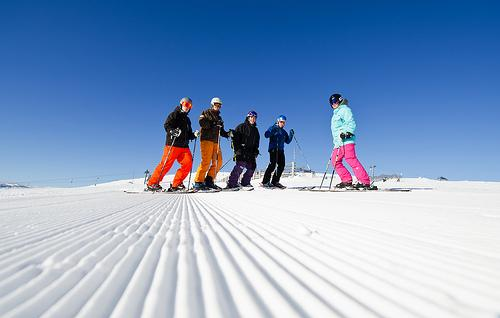Assess the sentiment conveyed by the image, taking into account the atmosphere and human activity. The image evokes a sense of excitement, joy and adventurousness, as people are enjoying skiing outdoors on a beautiful day with clear blue skies. Please point out the primary elements in this image, including the weather condition and the activity taking place. The image features clear blue skies with scattered white clouds, a snow-covered ground with tracks, five people skiing wearing helmets and ski pants in various colors, and holding ski poles. Examine the general atmosphere and scenery of the image described. The image showcases an outdoors scene with clear and blue skies, white clouds, and snow-covered ground, creating a serene and picturesque setting. Please count the number of people in this image and mention their primary activity. There are five people in the image, each of them engaging in skiing as their primary activity. Determine if there are any interactions between the objects or the people in the image. The skiers are interacting with the snow and their ski equipment, such as ski poles, helmets, and goggles, but no direct interaction between the skiers is visible. Perform an assessment of image quality by noting the clarity and level of detail provided. The image quality appears to be good, providing a clear view of the skies, snow, and skiers, including colors and sizes of each element. In this image, can you identify the number of skiers and the color of their ski pants? There are five skiers in the image, wearing ski pants in bright orange, light orange, red, hot pink, and baby blue colors. Analyze the presence of safety equipment on the skiers in the image, such as helmets and goggles. All five skiers are wearing helmets, with at least one white and one black helmet visible. One skier is specifically wearing orange goggles too. Provide a brief description of the weather and activity shown in the image. The image shows a beautiful day with a clear blue sky and white clouds, while a group of five people enjoy skiing outdoors on snow-covered slopes. Evaluate the complexity of reasoning required to understand the scene and the dynamics within the image. The scene demands a moderate level of reasoning as it involves understanding various elements such as weather, skiing activity, safety equipment, and a group of people enjoying the outdoors. Where is the tree in this outdoors scene? There is no mention of any trees in the image, only skies, clouds, skiers, and objects related to skiing. Can you find the skier without a helmet? All skiers are mentioned to be wearing helmets in the image (white, black and orange helmets), so there isn't any skier without a helmet. Can you identify the brown ski pole held by a man? There is only mention of a metal ski pole held by a woman in the image, not a brown ski pole held by a man. Where are the green ski jackets in the image? There are no green ski jackets in the image; only black and baby blue snow jackets are mentioned. Where are the purple goggles on any of the skiers? There are no purple goggles mentioned in the image; only orange goggles are mentioned. Can you spot the yellow snow pants in the image? There are no yellow snow pants in the image; only white, bright orange, light orange, and hot pink snow pants are mentioned. 